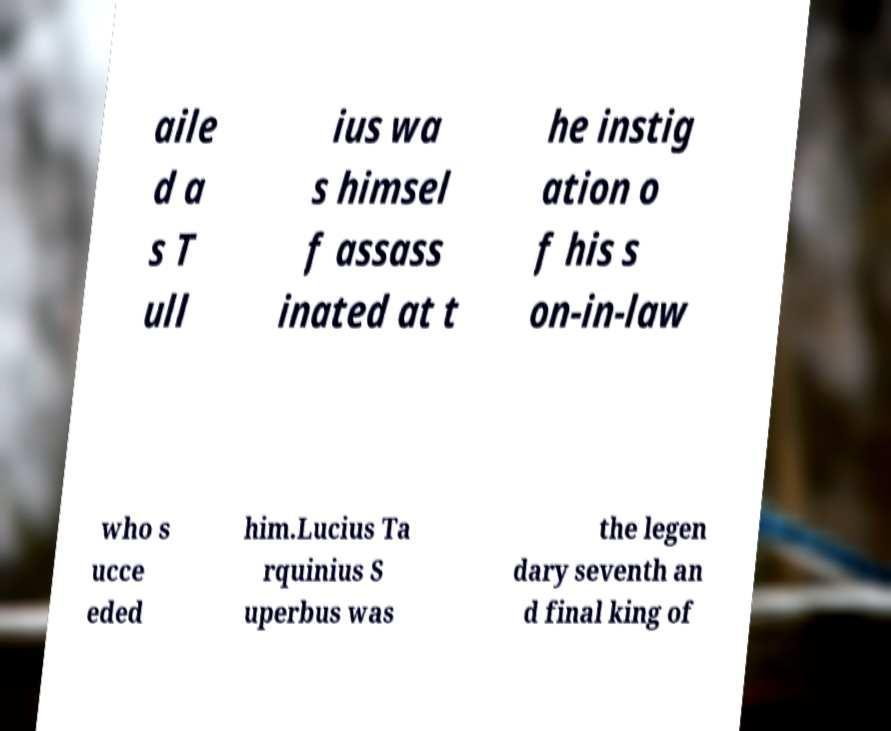Please read and relay the text visible in this image. What does it say? aile d a s T ull ius wa s himsel f assass inated at t he instig ation o f his s on-in-law who s ucce eded him.Lucius Ta rquinius S uperbus was the legen dary seventh an d final king of 